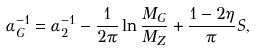Convert formula to latex. <formula><loc_0><loc_0><loc_500><loc_500>\alpha _ { G } ^ { - 1 } = \alpha _ { 2 } ^ { - 1 } - \frac { 1 } { 2 \pi } \ln { \frac { M _ { G } } { M _ { Z } } } + \frac { 1 - 2 \eta } { \pi } S ,</formula> 